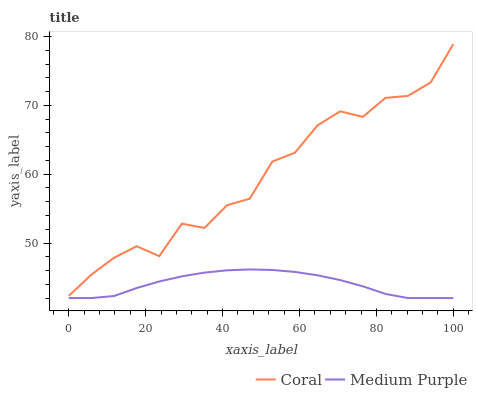Does Coral have the minimum area under the curve?
Answer yes or no. No. Is Coral the smoothest?
Answer yes or no. No. Does Coral have the lowest value?
Answer yes or no. No. Is Medium Purple less than Coral?
Answer yes or no. Yes. Is Coral greater than Medium Purple?
Answer yes or no. Yes. Does Medium Purple intersect Coral?
Answer yes or no. No. 